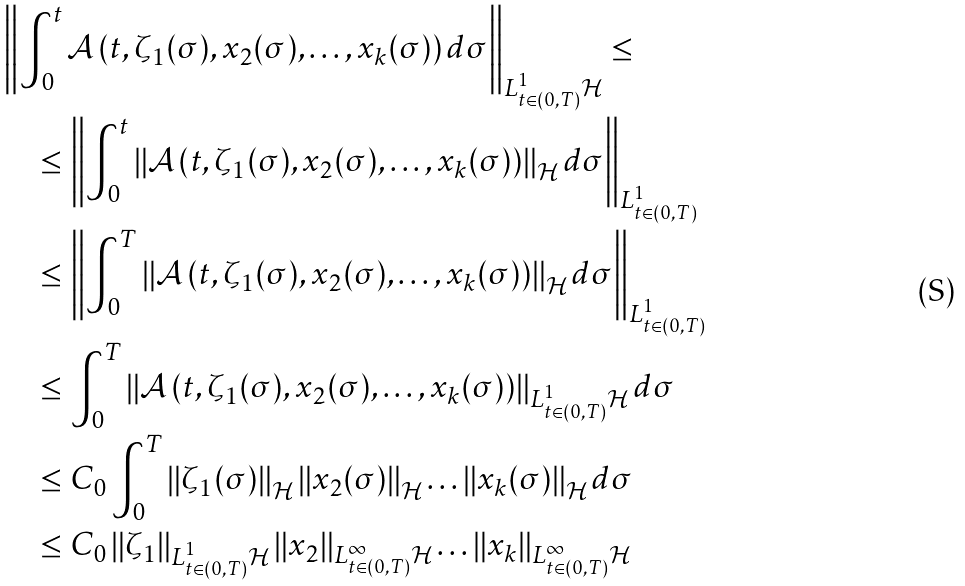Convert formula to latex. <formula><loc_0><loc_0><loc_500><loc_500>& \left \| \int _ { 0 } ^ { t } \mathcal { A } \left ( t , \zeta _ { 1 } ( \sigma ) , x _ { 2 } ( \sigma ) , \dots , x _ { k } ( \sigma ) \right ) d \sigma \right \| _ { L ^ { 1 } _ { t \in ( 0 , T ) } \mathcal { H } } \leq \\ & \quad \leq \left \| \int _ { 0 } ^ { t } \left \| \mathcal { A } \left ( t , \zeta _ { 1 } ( \sigma ) , x _ { 2 } ( \sigma ) , \dots , x _ { k } ( \sigma ) \right ) \right \| _ { \mathcal { H } } d \sigma \right \| _ { L ^ { 1 } _ { t \in ( 0 , T ) } } \\ & \quad \leq \left \| \int _ { 0 } ^ { T } \left \| \mathcal { A } \left ( t , \zeta _ { 1 } ( \sigma ) , x _ { 2 } ( \sigma ) , \dots , x _ { k } ( \sigma ) \right ) \right \| _ { \mathcal { H } } d \sigma \right \| _ { L ^ { 1 } _ { t \in ( 0 , T ) } } \\ & \quad \leq \int _ { 0 } ^ { T } \left \| \mathcal { A } \left ( t , \zeta _ { 1 } ( \sigma ) , x _ { 2 } ( \sigma ) , \dots , x _ { k } ( \sigma ) \right ) \right \| _ { L ^ { 1 } _ { t \in ( 0 , T ) } \mathcal { H } } d \sigma \\ & \quad \leq C _ { 0 } \int _ { 0 } ^ { T } \left \| \zeta _ { 1 } ( \sigma ) \right \| _ { \mathcal { H } } \left \| x _ { 2 } ( \sigma ) \right \| _ { \mathcal { H } } \dots \left \| x _ { k } ( \sigma ) \right \| _ { \mathcal { H } } d \sigma \\ & \quad \leq C _ { 0 } \left \| \zeta _ { 1 } \right \| _ { L ^ { 1 } _ { t \in ( 0 , T ) } \mathcal { H } } \left \| x _ { 2 } \right \| _ { L ^ { \infty } _ { t \in ( 0 , T ) } \mathcal { H } } \dots \left \| x _ { k } \right \| _ { L ^ { \infty } _ { t \in ( 0 , T ) } \mathcal { H } }</formula> 